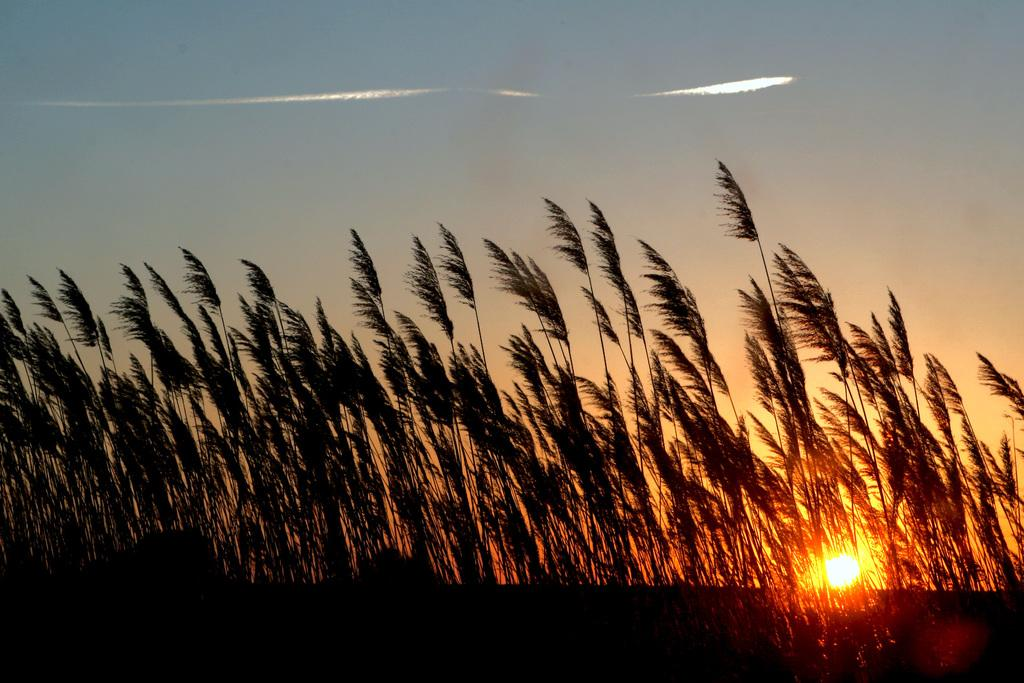What is located in the center of the image? There are trees in the center of the image. What celestial body can be seen in the image? The sun is visible in the image. What is visible at the top of the image? The sky is visible at the top of the image. Can you tell me how many people are jumping in the image? There are no people visible in the image, so it is not possible to determine how many might be jumping. What type of rice is being used to create the texture of the sky in the image? There is no rice present in the image, and the sky's texture is not created by rice. 